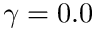Convert formula to latex. <formula><loc_0><loc_0><loc_500><loc_500>\gamma = 0 . 0</formula> 